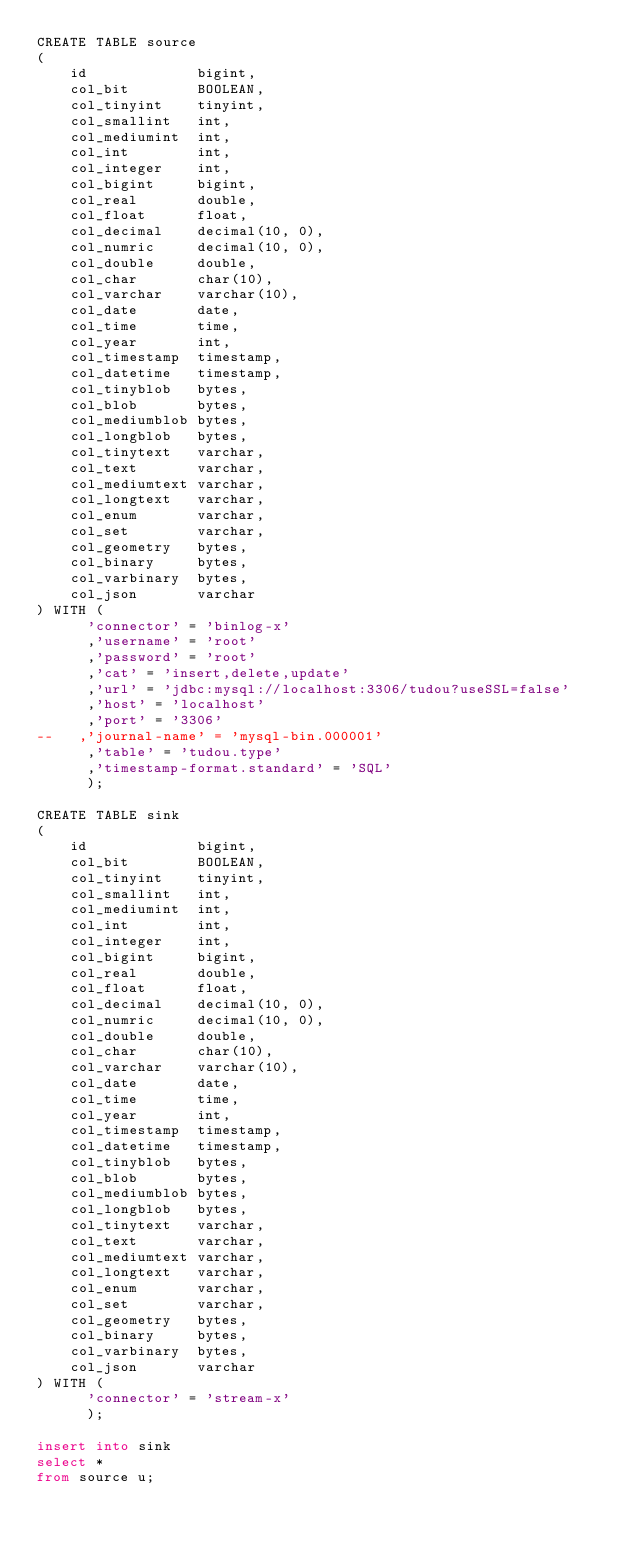<code> <loc_0><loc_0><loc_500><loc_500><_SQL_>CREATE TABLE source
(
    id             bigint,
    col_bit        BOOLEAN,
    col_tinyint    tinyint,
    col_smallint   int,
    col_mediumint  int,
    col_int        int,
    col_integer    int,
    col_bigint     bigint,
    col_real       double,
    col_float      float,
    col_decimal    decimal(10, 0),
    col_numric     decimal(10, 0),
    col_double     double,
    col_char       char(10),
    col_varchar    varchar(10),
    col_date       date,
    col_time       time,
    col_year       int,
    col_timestamp  timestamp,
    col_datetime   timestamp,
    col_tinyblob   bytes,
    col_blob       bytes,
    col_mediumblob bytes,
    col_longblob   bytes,
    col_tinytext   varchar,
    col_text       varchar,
    col_mediumtext varchar,
    col_longtext   varchar,
    col_enum       varchar,
    col_set        varchar,
    col_geometry   bytes,
    col_binary     bytes,
    col_varbinary  bytes,
    col_json       varchar
) WITH (
      'connector' = 'binlog-x'
      ,'username' = 'root'
      ,'password' = 'root'
      ,'cat' = 'insert,delete,update'
      ,'url' = 'jdbc:mysql://localhost:3306/tudou?useSSL=false'
      ,'host' = 'localhost'
      ,'port' = '3306'
--   ,'journal-name' = 'mysql-bin.000001'
      ,'table' = 'tudou.type'
      ,'timestamp-format.standard' = 'SQL'
      );

CREATE TABLE sink
(
    id             bigint,
    col_bit        BOOLEAN,
    col_tinyint    tinyint,
    col_smallint   int,
    col_mediumint  int,
    col_int        int,
    col_integer    int,
    col_bigint     bigint,
    col_real       double,
    col_float      float,
    col_decimal    decimal(10, 0),
    col_numric     decimal(10, 0),
    col_double     double,
    col_char       char(10),
    col_varchar    varchar(10),
    col_date       date,
    col_time       time,
    col_year       int,
    col_timestamp  timestamp,
    col_datetime   timestamp,
    col_tinyblob   bytes,
    col_blob       bytes,
    col_mediumblob bytes,
    col_longblob   bytes,
    col_tinytext   varchar,
    col_text       varchar,
    col_mediumtext varchar,
    col_longtext   varchar,
    col_enum       varchar,
    col_set        varchar,
    col_geometry   bytes,
    col_binary     bytes,
    col_varbinary  bytes,
    col_json       varchar
) WITH (
      'connector' = 'stream-x'
      );

insert into sink
select *
from source u;
</code> 